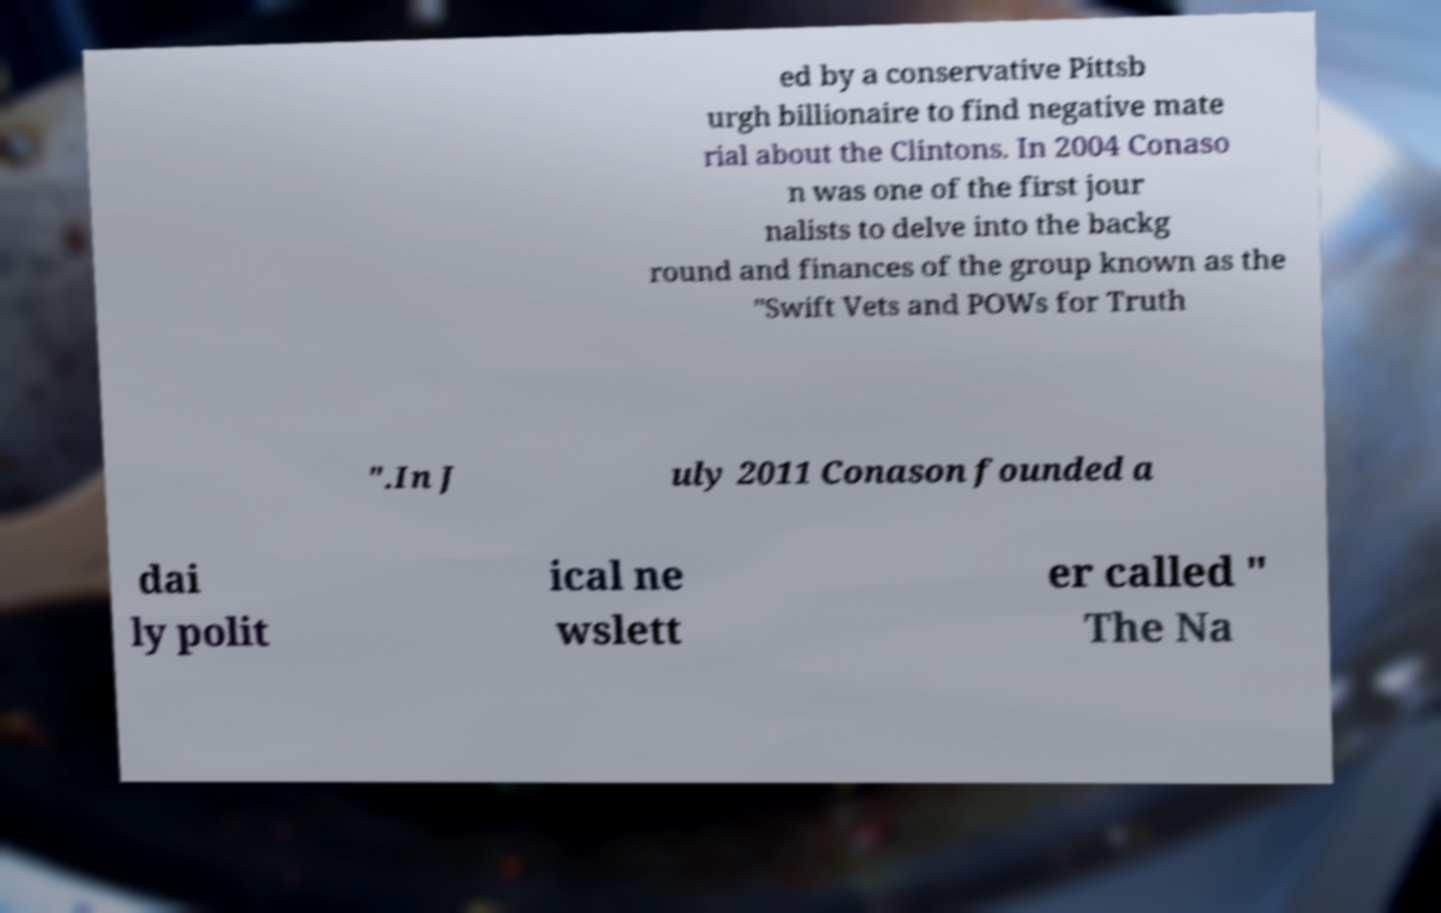For documentation purposes, I need the text within this image transcribed. Could you provide that? ed by a conservative Pittsb urgh billionaire to find negative mate rial about the Clintons. In 2004 Conaso n was one of the first jour nalists to delve into the backg round and finances of the group known as the "Swift Vets and POWs for Truth ".In J uly 2011 Conason founded a dai ly polit ical ne wslett er called " The Na 